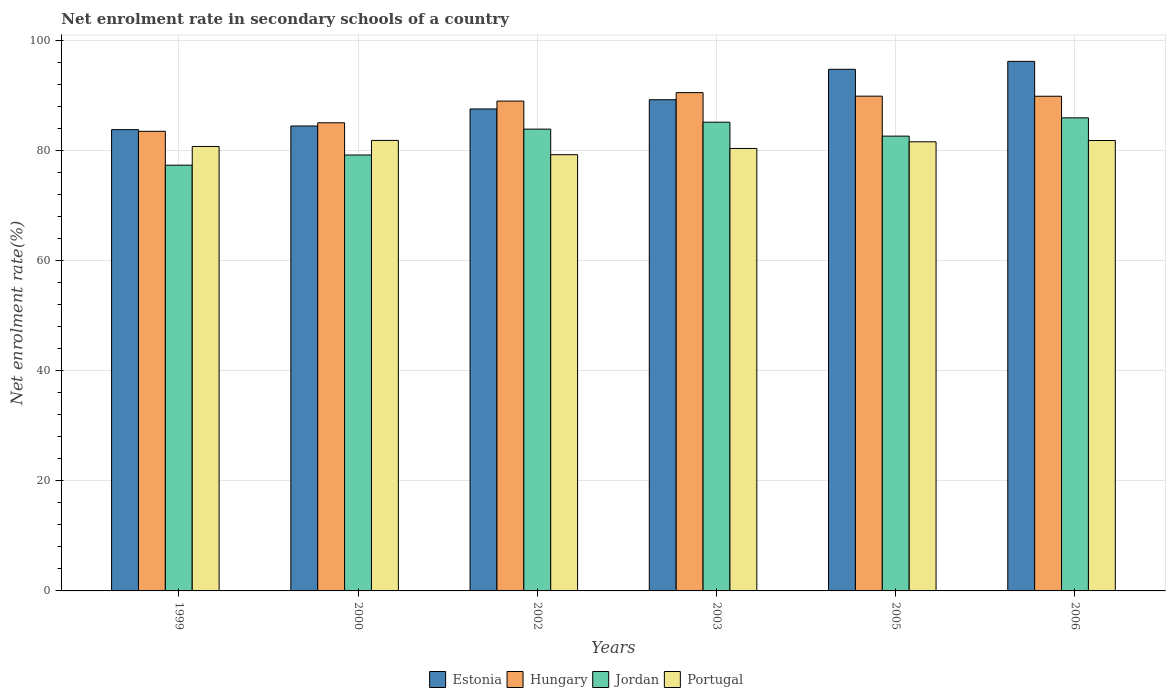How many different coloured bars are there?
Provide a short and direct response. 4. Are the number of bars on each tick of the X-axis equal?
Provide a succinct answer. Yes. How many bars are there on the 3rd tick from the right?
Offer a terse response. 4. What is the net enrolment rate in secondary schools in Hungary in 2005?
Your answer should be compact. 89.93. Across all years, what is the maximum net enrolment rate in secondary schools in Jordan?
Ensure brevity in your answer.  85.99. Across all years, what is the minimum net enrolment rate in secondary schools in Jordan?
Offer a very short reply. 77.39. In which year was the net enrolment rate in secondary schools in Jordan maximum?
Provide a succinct answer. 2006. In which year was the net enrolment rate in secondary schools in Hungary minimum?
Offer a very short reply. 1999. What is the total net enrolment rate in secondary schools in Estonia in the graph?
Offer a very short reply. 536.3. What is the difference between the net enrolment rate in secondary schools in Jordan in 2005 and that in 2006?
Ensure brevity in your answer.  -3.32. What is the difference between the net enrolment rate in secondary schools in Hungary in 2005 and the net enrolment rate in secondary schools in Portugal in 2002?
Provide a short and direct response. 10.64. What is the average net enrolment rate in secondary schools in Jordan per year?
Your response must be concise. 82.4. In the year 2002, what is the difference between the net enrolment rate in secondary schools in Portugal and net enrolment rate in secondary schools in Jordan?
Your response must be concise. -4.65. What is the ratio of the net enrolment rate in secondary schools in Portugal in 2003 to that in 2005?
Offer a terse response. 0.99. Is the difference between the net enrolment rate in secondary schools in Portugal in 2003 and 2006 greater than the difference between the net enrolment rate in secondary schools in Jordan in 2003 and 2006?
Offer a very short reply. No. What is the difference between the highest and the second highest net enrolment rate in secondary schools in Portugal?
Your answer should be compact. 0.02. What is the difference between the highest and the lowest net enrolment rate in secondary schools in Estonia?
Give a very brief answer. 12.41. Is the sum of the net enrolment rate in secondary schools in Portugal in 1999 and 2000 greater than the maximum net enrolment rate in secondary schools in Estonia across all years?
Provide a succinct answer. Yes. What does the 3rd bar from the left in 2003 represents?
Offer a very short reply. Jordan. Is it the case that in every year, the sum of the net enrolment rate in secondary schools in Jordan and net enrolment rate in secondary schools in Hungary is greater than the net enrolment rate in secondary schools in Estonia?
Your response must be concise. Yes. How many bars are there?
Provide a short and direct response. 24. Are the values on the major ticks of Y-axis written in scientific E-notation?
Your answer should be compact. No. How many legend labels are there?
Make the answer very short. 4. How are the legend labels stacked?
Make the answer very short. Horizontal. What is the title of the graph?
Your answer should be very brief. Net enrolment rate in secondary schools of a country. Does "Sweden" appear as one of the legend labels in the graph?
Make the answer very short. No. What is the label or title of the Y-axis?
Offer a very short reply. Net enrolment rate(%). What is the Net enrolment rate(%) in Estonia in 1999?
Your answer should be compact. 83.84. What is the Net enrolment rate(%) of Hungary in 1999?
Offer a terse response. 83.54. What is the Net enrolment rate(%) of Jordan in 1999?
Your response must be concise. 77.39. What is the Net enrolment rate(%) of Portugal in 1999?
Your answer should be very brief. 80.78. What is the Net enrolment rate(%) in Estonia in 2000?
Your answer should be compact. 84.51. What is the Net enrolment rate(%) of Hungary in 2000?
Ensure brevity in your answer.  85.09. What is the Net enrolment rate(%) of Jordan in 2000?
Offer a terse response. 79.23. What is the Net enrolment rate(%) in Portugal in 2000?
Your answer should be compact. 81.89. What is the Net enrolment rate(%) of Estonia in 2002?
Give a very brief answer. 87.6. What is the Net enrolment rate(%) in Hungary in 2002?
Offer a terse response. 89.03. What is the Net enrolment rate(%) in Jordan in 2002?
Provide a short and direct response. 83.94. What is the Net enrolment rate(%) in Portugal in 2002?
Offer a terse response. 79.29. What is the Net enrolment rate(%) of Estonia in 2003?
Give a very brief answer. 89.28. What is the Net enrolment rate(%) in Hungary in 2003?
Give a very brief answer. 90.57. What is the Net enrolment rate(%) in Jordan in 2003?
Offer a very short reply. 85.2. What is the Net enrolment rate(%) of Portugal in 2003?
Your answer should be very brief. 80.42. What is the Net enrolment rate(%) in Estonia in 2005?
Provide a short and direct response. 94.81. What is the Net enrolment rate(%) of Hungary in 2005?
Give a very brief answer. 89.93. What is the Net enrolment rate(%) in Jordan in 2005?
Offer a terse response. 82.66. What is the Net enrolment rate(%) of Portugal in 2005?
Your answer should be very brief. 81.64. What is the Net enrolment rate(%) of Estonia in 2006?
Your response must be concise. 96.26. What is the Net enrolment rate(%) in Hungary in 2006?
Provide a short and direct response. 89.91. What is the Net enrolment rate(%) in Jordan in 2006?
Your answer should be compact. 85.99. What is the Net enrolment rate(%) of Portugal in 2006?
Your answer should be very brief. 81.87. Across all years, what is the maximum Net enrolment rate(%) in Estonia?
Provide a succinct answer. 96.26. Across all years, what is the maximum Net enrolment rate(%) of Hungary?
Your response must be concise. 90.57. Across all years, what is the maximum Net enrolment rate(%) in Jordan?
Offer a terse response. 85.99. Across all years, what is the maximum Net enrolment rate(%) of Portugal?
Your answer should be very brief. 81.89. Across all years, what is the minimum Net enrolment rate(%) in Estonia?
Offer a very short reply. 83.84. Across all years, what is the minimum Net enrolment rate(%) in Hungary?
Your response must be concise. 83.54. Across all years, what is the minimum Net enrolment rate(%) of Jordan?
Your answer should be very brief. 77.39. Across all years, what is the minimum Net enrolment rate(%) of Portugal?
Offer a very short reply. 79.29. What is the total Net enrolment rate(%) in Estonia in the graph?
Your response must be concise. 536.3. What is the total Net enrolment rate(%) of Hungary in the graph?
Ensure brevity in your answer.  528.08. What is the total Net enrolment rate(%) in Jordan in the graph?
Give a very brief answer. 494.41. What is the total Net enrolment rate(%) in Portugal in the graph?
Ensure brevity in your answer.  485.89. What is the difference between the Net enrolment rate(%) in Estonia in 1999 and that in 2000?
Your answer should be compact. -0.66. What is the difference between the Net enrolment rate(%) of Hungary in 1999 and that in 2000?
Your answer should be compact. -1.55. What is the difference between the Net enrolment rate(%) of Jordan in 1999 and that in 2000?
Your response must be concise. -1.85. What is the difference between the Net enrolment rate(%) of Portugal in 1999 and that in 2000?
Your response must be concise. -1.1. What is the difference between the Net enrolment rate(%) in Estonia in 1999 and that in 2002?
Offer a terse response. -3.76. What is the difference between the Net enrolment rate(%) in Hungary in 1999 and that in 2002?
Your answer should be very brief. -5.49. What is the difference between the Net enrolment rate(%) in Jordan in 1999 and that in 2002?
Ensure brevity in your answer.  -6.55. What is the difference between the Net enrolment rate(%) in Portugal in 1999 and that in 2002?
Your response must be concise. 1.49. What is the difference between the Net enrolment rate(%) in Estonia in 1999 and that in 2003?
Make the answer very short. -5.44. What is the difference between the Net enrolment rate(%) of Hungary in 1999 and that in 2003?
Offer a terse response. -7.03. What is the difference between the Net enrolment rate(%) in Jordan in 1999 and that in 2003?
Keep it short and to the point. -7.81. What is the difference between the Net enrolment rate(%) in Portugal in 1999 and that in 2003?
Ensure brevity in your answer.  0.36. What is the difference between the Net enrolment rate(%) in Estonia in 1999 and that in 2005?
Your answer should be compact. -10.97. What is the difference between the Net enrolment rate(%) in Hungary in 1999 and that in 2005?
Ensure brevity in your answer.  -6.39. What is the difference between the Net enrolment rate(%) of Jordan in 1999 and that in 2005?
Offer a terse response. -5.28. What is the difference between the Net enrolment rate(%) in Portugal in 1999 and that in 2005?
Your answer should be compact. -0.85. What is the difference between the Net enrolment rate(%) of Estonia in 1999 and that in 2006?
Your response must be concise. -12.41. What is the difference between the Net enrolment rate(%) in Hungary in 1999 and that in 2006?
Your answer should be compact. -6.37. What is the difference between the Net enrolment rate(%) in Jordan in 1999 and that in 2006?
Your response must be concise. -8.6. What is the difference between the Net enrolment rate(%) of Portugal in 1999 and that in 2006?
Give a very brief answer. -1.09. What is the difference between the Net enrolment rate(%) in Estonia in 2000 and that in 2002?
Offer a very short reply. -3.1. What is the difference between the Net enrolment rate(%) in Hungary in 2000 and that in 2002?
Ensure brevity in your answer.  -3.95. What is the difference between the Net enrolment rate(%) of Jordan in 2000 and that in 2002?
Give a very brief answer. -4.7. What is the difference between the Net enrolment rate(%) of Portugal in 2000 and that in 2002?
Your answer should be very brief. 2.6. What is the difference between the Net enrolment rate(%) in Estonia in 2000 and that in 2003?
Offer a very short reply. -4.78. What is the difference between the Net enrolment rate(%) of Hungary in 2000 and that in 2003?
Your answer should be very brief. -5.48. What is the difference between the Net enrolment rate(%) of Jordan in 2000 and that in 2003?
Your answer should be very brief. -5.97. What is the difference between the Net enrolment rate(%) in Portugal in 2000 and that in 2003?
Ensure brevity in your answer.  1.46. What is the difference between the Net enrolment rate(%) of Estonia in 2000 and that in 2005?
Offer a terse response. -10.31. What is the difference between the Net enrolment rate(%) of Hungary in 2000 and that in 2005?
Keep it short and to the point. -4.84. What is the difference between the Net enrolment rate(%) in Jordan in 2000 and that in 2005?
Your response must be concise. -3.43. What is the difference between the Net enrolment rate(%) in Estonia in 2000 and that in 2006?
Your answer should be compact. -11.75. What is the difference between the Net enrolment rate(%) in Hungary in 2000 and that in 2006?
Make the answer very short. -4.83. What is the difference between the Net enrolment rate(%) of Jordan in 2000 and that in 2006?
Your answer should be compact. -6.76. What is the difference between the Net enrolment rate(%) in Portugal in 2000 and that in 2006?
Offer a terse response. 0.02. What is the difference between the Net enrolment rate(%) in Estonia in 2002 and that in 2003?
Your response must be concise. -1.68. What is the difference between the Net enrolment rate(%) in Hungary in 2002 and that in 2003?
Keep it short and to the point. -1.54. What is the difference between the Net enrolment rate(%) in Jordan in 2002 and that in 2003?
Provide a succinct answer. -1.26. What is the difference between the Net enrolment rate(%) of Portugal in 2002 and that in 2003?
Make the answer very short. -1.13. What is the difference between the Net enrolment rate(%) in Estonia in 2002 and that in 2005?
Make the answer very short. -7.21. What is the difference between the Net enrolment rate(%) of Hungary in 2002 and that in 2005?
Provide a short and direct response. -0.89. What is the difference between the Net enrolment rate(%) in Jordan in 2002 and that in 2005?
Provide a short and direct response. 1.27. What is the difference between the Net enrolment rate(%) of Portugal in 2002 and that in 2005?
Make the answer very short. -2.35. What is the difference between the Net enrolment rate(%) of Estonia in 2002 and that in 2006?
Provide a short and direct response. -8.65. What is the difference between the Net enrolment rate(%) of Hungary in 2002 and that in 2006?
Make the answer very short. -0.88. What is the difference between the Net enrolment rate(%) of Jordan in 2002 and that in 2006?
Offer a very short reply. -2.05. What is the difference between the Net enrolment rate(%) in Portugal in 2002 and that in 2006?
Offer a very short reply. -2.58. What is the difference between the Net enrolment rate(%) of Estonia in 2003 and that in 2005?
Offer a terse response. -5.53. What is the difference between the Net enrolment rate(%) in Hungary in 2003 and that in 2005?
Your answer should be very brief. 0.64. What is the difference between the Net enrolment rate(%) in Jordan in 2003 and that in 2005?
Offer a terse response. 2.53. What is the difference between the Net enrolment rate(%) of Portugal in 2003 and that in 2005?
Offer a very short reply. -1.21. What is the difference between the Net enrolment rate(%) in Estonia in 2003 and that in 2006?
Provide a succinct answer. -6.97. What is the difference between the Net enrolment rate(%) of Hungary in 2003 and that in 2006?
Provide a short and direct response. 0.66. What is the difference between the Net enrolment rate(%) of Jordan in 2003 and that in 2006?
Your answer should be very brief. -0.79. What is the difference between the Net enrolment rate(%) of Portugal in 2003 and that in 2006?
Offer a terse response. -1.45. What is the difference between the Net enrolment rate(%) of Estonia in 2005 and that in 2006?
Make the answer very short. -1.44. What is the difference between the Net enrolment rate(%) in Hungary in 2005 and that in 2006?
Give a very brief answer. 0.01. What is the difference between the Net enrolment rate(%) in Jordan in 2005 and that in 2006?
Offer a terse response. -3.32. What is the difference between the Net enrolment rate(%) of Portugal in 2005 and that in 2006?
Provide a short and direct response. -0.23. What is the difference between the Net enrolment rate(%) of Estonia in 1999 and the Net enrolment rate(%) of Hungary in 2000?
Offer a very short reply. -1.25. What is the difference between the Net enrolment rate(%) of Estonia in 1999 and the Net enrolment rate(%) of Jordan in 2000?
Make the answer very short. 4.61. What is the difference between the Net enrolment rate(%) in Estonia in 1999 and the Net enrolment rate(%) in Portugal in 2000?
Your answer should be very brief. 1.96. What is the difference between the Net enrolment rate(%) of Hungary in 1999 and the Net enrolment rate(%) of Jordan in 2000?
Offer a terse response. 4.31. What is the difference between the Net enrolment rate(%) in Hungary in 1999 and the Net enrolment rate(%) in Portugal in 2000?
Give a very brief answer. 1.66. What is the difference between the Net enrolment rate(%) in Jordan in 1999 and the Net enrolment rate(%) in Portugal in 2000?
Offer a very short reply. -4.5. What is the difference between the Net enrolment rate(%) in Estonia in 1999 and the Net enrolment rate(%) in Hungary in 2002?
Your response must be concise. -5.19. What is the difference between the Net enrolment rate(%) of Estonia in 1999 and the Net enrolment rate(%) of Jordan in 2002?
Provide a short and direct response. -0.1. What is the difference between the Net enrolment rate(%) in Estonia in 1999 and the Net enrolment rate(%) in Portugal in 2002?
Make the answer very short. 4.55. What is the difference between the Net enrolment rate(%) in Hungary in 1999 and the Net enrolment rate(%) in Jordan in 2002?
Provide a succinct answer. -0.39. What is the difference between the Net enrolment rate(%) of Hungary in 1999 and the Net enrolment rate(%) of Portugal in 2002?
Offer a terse response. 4.25. What is the difference between the Net enrolment rate(%) of Jordan in 1999 and the Net enrolment rate(%) of Portugal in 2002?
Offer a very short reply. -1.91. What is the difference between the Net enrolment rate(%) of Estonia in 1999 and the Net enrolment rate(%) of Hungary in 2003?
Offer a terse response. -6.73. What is the difference between the Net enrolment rate(%) of Estonia in 1999 and the Net enrolment rate(%) of Jordan in 2003?
Keep it short and to the point. -1.36. What is the difference between the Net enrolment rate(%) of Estonia in 1999 and the Net enrolment rate(%) of Portugal in 2003?
Keep it short and to the point. 3.42. What is the difference between the Net enrolment rate(%) of Hungary in 1999 and the Net enrolment rate(%) of Jordan in 2003?
Offer a very short reply. -1.66. What is the difference between the Net enrolment rate(%) in Hungary in 1999 and the Net enrolment rate(%) in Portugal in 2003?
Provide a succinct answer. 3.12. What is the difference between the Net enrolment rate(%) in Jordan in 1999 and the Net enrolment rate(%) in Portugal in 2003?
Offer a terse response. -3.04. What is the difference between the Net enrolment rate(%) in Estonia in 1999 and the Net enrolment rate(%) in Hungary in 2005?
Your answer should be very brief. -6.09. What is the difference between the Net enrolment rate(%) of Estonia in 1999 and the Net enrolment rate(%) of Jordan in 2005?
Your response must be concise. 1.18. What is the difference between the Net enrolment rate(%) of Estonia in 1999 and the Net enrolment rate(%) of Portugal in 2005?
Provide a succinct answer. 2.21. What is the difference between the Net enrolment rate(%) of Hungary in 1999 and the Net enrolment rate(%) of Jordan in 2005?
Your answer should be very brief. 0.88. What is the difference between the Net enrolment rate(%) of Hungary in 1999 and the Net enrolment rate(%) of Portugal in 2005?
Your answer should be very brief. 1.91. What is the difference between the Net enrolment rate(%) in Jordan in 1999 and the Net enrolment rate(%) in Portugal in 2005?
Provide a short and direct response. -4.25. What is the difference between the Net enrolment rate(%) of Estonia in 1999 and the Net enrolment rate(%) of Hungary in 2006?
Provide a succinct answer. -6.07. What is the difference between the Net enrolment rate(%) in Estonia in 1999 and the Net enrolment rate(%) in Jordan in 2006?
Keep it short and to the point. -2.15. What is the difference between the Net enrolment rate(%) in Estonia in 1999 and the Net enrolment rate(%) in Portugal in 2006?
Provide a short and direct response. 1.97. What is the difference between the Net enrolment rate(%) in Hungary in 1999 and the Net enrolment rate(%) in Jordan in 2006?
Your answer should be compact. -2.44. What is the difference between the Net enrolment rate(%) in Hungary in 1999 and the Net enrolment rate(%) in Portugal in 2006?
Provide a succinct answer. 1.67. What is the difference between the Net enrolment rate(%) of Jordan in 1999 and the Net enrolment rate(%) of Portugal in 2006?
Make the answer very short. -4.48. What is the difference between the Net enrolment rate(%) of Estonia in 2000 and the Net enrolment rate(%) of Hungary in 2002?
Keep it short and to the point. -4.53. What is the difference between the Net enrolment rate(%) in Estonia in 2000 and the Net enrolment rate(%) in Jordan in 2002?
Provide a succinct answer. 0.57. What is the difference between the Net enrolment rate(%) in Estonia in 2000 and the Net enrolment rate(%) in Portugal in 2002?
Your answer should be very brief. 5.22. What is the difference between the Net enrolment rate(%) of Hungary in 2000 and the Net enrolment rate(%) of Jordan in 2002?
Keep it short and to the point. 1.15. What is the difference between the Net enrolment rate(%) in Hungary in 2000 and the Net enrolment rate(%) in Portugal in 2002?
Your response must be concise. 5.8. What is the difference between the Net enrolment rate(%) of Jordan in 2000 and the Net enrolment rate(%) of Portugal in 2002?
Your response must be concise. -0.06. What is the difference between the Net enrolment rate(%) of Estonia in 2000 and the Net enrolment rate(%) of Hungary in 2003?
Provide a short and direct response. -6.07. What is the difference between the Net enrolment rate(%) in Estonia in 2000 and the Net enrolment rate(%) in Jordan in 2003?
Give a very brief answer. -0.69. What is the difference between the Net enrolment rate(%) in Estonia in 2000 and the Net enrolment rate(%) in Portugal in 2003?
Offer a terse response. 4.08. What is the difference between the Net enrolment rate(%) in Hungary in 2000 and the Net enrolment rate(%) in Jordan in 2003?
Offer a very short reply. -0.11. What is the difference between the Net enrolment rate(%) of Hungary in 2000 and the Net enrolment rate(%) of Portugal in 2003?
Your answer should be compact. 4.66. What is the difference between the Net enrolment rate(%) of Jordan in 2000 and the Net enrolment rate(%) of Portugal in 2003?
Ensure brevity in your answer.  -1.19. What is the difference between the Net enrolment rate(%) of Estonia in 2000 and the Net enrolment rate(%) of Hungary in 2005?
Provide a short and direct response. -5.42. What is the difference between the Net enrolment rate(%) in Estonia in 2000 and the Net enrolment rate(%) in Jordan in 2005?
Your answer should be compact. 1.84. What is the difference between the Net enrolment rate(%) of Estonia in 2000 and the Net enrolment rate(%) of Portugal in 2005?
Offer a very short reply. 2.87. What is the difference between the Net enrolment rate(%) in Hungary in 2000 and the Net enrolment rate(%) in Jordan in 2005?
Provide a succinct answer. 2.42. What is the difference between the Net enrolment rate(%) of Hungary in 2000 and the Net enrolment rate(%) of Portugal in 2005?
Your answer should be very brief. 3.45. What is the difference between the Net enrolment rate(%) in Jordan in 2000 and the Net enrolment rate(%) in Portugal in 2005?
Keep it short and to the point. -2.4. What is the difference between the Net enrolment rate(%) in Estonia in 2000 and the Net enrolment rate(%) in Hungary in 2006?
Offer a very short reply. -5.41. What is the difference between the Net enrolment rate(%) of Estonia in 2000 and the Net enrolment rate(%) of Jordan in 2006?
Ensure brevity in your answer.  -1.48. What is the difference between the Net enrolment rate(%) in Estonia in 2000 and the Net enrolment rate(%) in Portugal in 2006?
Provide a short and direct response. 2.64. What is the difference between the Net enrolment rate(%) in Hungary in 2000 and the Net enrolment rate(%) in Jordan in 2006?
Offer a terse response. -0.9. What is the difference between the Net enrolment rate(%) in Hungary in 2000 and the Net enrolment rate(%) in Portugal in 2006?
Ensure brevity in your answer.  3.22. What is the difference between the Net enrolment rate(%) of Jordan in 2000 and the Net enrolment rate(%) of Portugal in 2006?
Offer a terse response. -2.64. What is the difference between the Net enrolment rate(%) of Estonia in 2002 and the Net enrolment rate(%) of Hungary in 2003?
Your response must be concise. -2.97. What is the difference between the Net enrolment rate(%) in Estonia in 2002 and the Net enrolment rate(%) in Jordan in 2003?
Make the answer very short. 2.4. What is the difference between the Net enrolment rate(%) in Estonia in 2002 and the Net enrolment rate(%) in Portugal in 2003?
Keep it short and to the point. 7.18. What is the difference between the Net enrolment rate(%) in Hungary in 2002 and the Net enrolment rate(%) in Jordan in 2003?
Make the answer very short. 3.84. What is the difference between the Net enrolment rate(%) of Hungary in 2002 and the Net enrolment rate(%) of Portugal in 2003?
Offer a very short reply. 8.61. What is the difference between the Net enrolment rate(%) of Jordan in 2002 and the Net enrolment rate(%) of Portugal in 2003?
Provide a short and direct response. 3.51. What is the difference between the Net enrolment rate(%) in Estonia in 2002 and the Net enrolment rate(%) in Hungary in 2005?
Make the answer very short. -2.33. What is the difference between the Net enrolment rate(%) in Estonia in 2002 and the Net enrolment rate(%) in Jordan in 2005?
Your answer should be compact. 4.94. What is the difference between the Net enrolment rate(%) in Estonia in 2002 and the Net enrolment rate(%) in Portugal in 2005?
Your answer should be very brief. 5.97. What is the difference between the Net enrolment rate(%) in Hungary in 2002 and the Net enrolment rate(%) in Jordan in 2005?
Make the answer very short. 6.37. What is the difference between the Net enrolment rate(%) in Hungary in 2002 and the Net enrolment rate(%) in Portugal in 2005?
Provide a short and direct response. 7.4. What is the difference between the Net enrolment rate(%) in Jordan in 2002 and the Net enrolment rate(%) in Portugal in 2005?
Ensure brevity in your answer.  2.3. What is the difference between the Net enrolment rate(%) of Estonia in 2002 and the Net enrolment rate(%) of Hungary in 2006?
Keep it short and to the point. -2.31. What is the difference between the Net enrolment rate(%) of Estonia in 2002 and the Net enrolment rate(%) of Jordan in 2006?
Provide a short and direct response. 1.62. What is the difference between the Net enrolment rate(%) in Estonia in 2002 and the Net enrolment rate(%) in Portugal in 2006?
Make the answer very short. 5.73. What is the difference between the Net enrolment rate(%) in Hungary in 2002 and the Net enrolment rate(%) in Jordan in 2006?
Make the answer very short. 3.05. What is the difference between the Net enrolment rate(%) in Hungary in 2002 and the Net enrolment rate(%) in Portugal in 2006?
Make the answer very short. 7.17. What is the difference between the Net enrolment rate(%) of Jordan in 2002 and the Net enrolment rate(%) of Portugal in 2006?
Your response must be concise. 2.07. What is the difference between the Net enrolment rate(%) of Estonia in 2003 and the Net enrolment rate(%) of Hungary in 2005?
Your answer should be very brief. -0.65. What is the difference between the Net enrolment rate(%) in Estonia in 2003 and the Net enrolment rate(%) in Jordan in 2005?
Make the answer very short. 6.62. What is the difference between the Net enrolment rate(%) in Estonia in 2003 and the Net enrolment rate(%) in Portugal in 2005?
Offer a terse response. 7.65. What is the difference between the Net enrolment rate(%) of Hungary in 2003 and the Net enrolment rate(%) of Jordan in 2005?
Provide a short and direct response. 7.91. What is the difference between the Net enrolment rate(%) in Hungary in 2003 and the Net enrolment rate(%) in Portugal in 2005?
Keep it short and to the point. 8.94. What is the difference between the Net enrolment rate(%) of Jordan in 2003 and the Net enrolment rate(%) of Portugal in 2005?
Provide a succinct answer. 3.56. What is the difference between the Net enrolment rate(%) of Estonia in 2003 and the Net enrolment rate(%) of Hungary in 2006?
Ensure brevity in your answer.  -0.63. What is the difference between the Net enrolment rate(%) of Estonia in 2003 and the Net enrolment rate(%) of Jordan in 2006?
Provide a short and direct response. 3.29. What is the difference between the Net enrolment rate(%) in Estonia in 2003 and the Net enrolment rate(%) in Portugal in 2006?
Offer a terse response. 7.41. What is the difference between the Net enrolment rate(%) in Hungary in 2003 and the Net enrolment rate(%) in Jordan in 2006?
Provide a succinct answer. 4.58. What is the difference between the Net enrolment rate(%) of Hungary in 2003 and the Net enrolment rate(%) of Portugal in 2006?
Ensure brevity in your answer.  8.7. What is the difference between the Net enrolment rate(%) in Jordan in 2003 and the Net enrolment rate(%) in Portugal in 2006?
Offer a terse response. 3.33. What is the difference between the Net enrolment rate(%) in Estonia in 2005 and the Net enrolment rate(%) in Hungary in 2006?
Ensure brevity in your answer.  4.9. What is the difference between the Net enrolment rate(%) of Estonia in 2005 and the Net enrolment rate(%) of Jordan in 2006?
Your response must be concise. 8.83. What is the difference between the Net enrolment rate(%) in Estonia in 2005 and the Net enrolment rate(%) in Portugal in 2006?
Provide a succinct answer. 12.94. What is the difference between the Net enrolment rate(%) in Hungary in 2005 and the Net enrolment rate(%) in Jordan in 2006?
Keep it short and to the point. 3.94. What is the difference between the Net enrolment rate(%) in Hungary in 2005 and the Net enrolment rate(%) in Portugal in 2006?
Ensure brevity in your answer.  8.06. What is the difference between the Net enrolment rate(%) of Jordan in 2005 and the Net enrolment rate(%) of Portugal in 2006?
Offer a terse response. 0.79. What is the average Net enrolment rate(%) in Estonia per year?
Provide a succinct answer. 89.38. What is the average Net enrolment rate(%) in Hungary per year?
Keep it short and to the point. 88.01. What is the average Net enrolment rate(%) of Jordan per year?
Make the answer very short. 82.4. What is the average Net enrolment rate(%) of Portugal per year?
Ensure brevity in your answer.  80.98. In the year 1999, what is the difference between the Net enrolment rate(%) in Estonia and Net enrolment rate(%) in Hungary?
Your answer should be compact. 0.3. In the year 1999, what is the difference between the Net enrolment rate(%) in Estonia and Net enrolment rate(%) in Jordan?
Give a very brief answer. 6.46. In the year 1999, what is the difference between the Net enrolment rate(%) of Estonia and Net enrolment rate(%) of Portugal?
Keep it short and to the point. 3.06. In the year 1999, what is the difference between the Net enrolment rate(%) in Hungary and Net enrolment rate(%) in Jordan?
Offer a terse response. 6.16. In the year 1999, what is the difference between the Net enrolment rate(%) in Hungary and Net enrolment rate(%) in Portugal?
Your answer should be very brief. 2.76. In the year 1999, what is the difference between the Net enrolment rate(%) of Jordan and Net enrolment rate(%) of Portugal?
Ensure brevity in your answer.  -3.4. In the year 2000, what is the difference between the Net enrolment rate(%) of Estonia and Net enrolment rate(%) of Hungary?
Keep it short and to the point. -0.58. In the year 2000, what is the difference between the Net enrolment rate(%) of Estonia and Net enrolment rate(%) of Jordan?
Your answer should be compact. 5.27. In the year 2000, what is the difference between the Net enrolment rate(%) of Estonia and Net enrolment rate(%) of Portugal?
Give a very brief answer. 2.62. In the year 2000, what is the difference between the Net enrolment rate(%) in Hungary and Net enrolment rate(%) in Jordan?
Your response must be concise. 5.86. In the year 2000, what is the difference between the Net enrolment rate(%) of Hungary and Net enrolment rate(%) of Portugal?
Ensure brevity in your answer.  3.2. In the year 2000, what is the difference between the Net enrolment rate(%) in Jordan and Net enrolment rate(%) in Portugal?
Make the answer very short. -2.65. In the year 2002, what is the difference between the Net enrolment rate(%) in Estonia and Net enrolment rate(%) in Hungary?
Give a very brief answer. -1.43. In the year 2002, what is the difference between the Net enrolment rate(%) of Estonia and Net enrolment rate(%) of Jordan?
Provide a succinct answer. 3.67. In the year 2002, what is the difference between the Net enrolment rate(%) in Estonia and Net enrolment rate(%) in Portugal?
Your answer should be very brief. 8.31. In the year 2002, what is the difference between the Net enrolment rate(%) in Hungary and Net enrolment rate(%) in Jordan?
Give a very brief answer. 5.1. In the year 2002, what is the difference between the Net enrolment rate(%) in Hungary and Net enrolment rate(%) in Portugal?
Give a very brief answer. 9.74. In the year 2002, what is the difference between the Net enrolment rate(%) in Jordan and Net enrolment rate(%) in Portugal?
Keep it short and to the point. 4.65. In the year 2003, what is the difference between the Net enrolment rate(%) in Estonia and Net enrolment rate(%) in Hungary?
Offer a terse response. -1.29. In the year 2003, what is the difference between the Net enrolment rate(%) of Estonia and Net enrolment rate(%) of Jordan?
Keep it short and to the point. 4.08. In the year 2003, what is the difference between the Net enrolment rate(%) of Estonia and Net enrolment rate(%) of Portugal?
Your response must be concise. 8.86. In the year 2003, what is the difference between the Net enrolment rate(%) of Hungary and Net enrolment rate(%) of Jordan?
Your response must be concise. 5.37. In the year 2003, what is the difference between the Net enrolment rate(%) of Hungary and Net enrolment rate(%) of Portugal?
Provide a short and direct response. 10.15. In the year 2003, what is the difference between the Net enrolment rate(%) in Jordan and Net enrolment rate(%) in Portugal?
Make the answer very short. 4.77. In the year 2005, what is the difference between the Net enrolment rate(%) in Estonia and Net enrolment rate(%) in Hungary?
Make the answer very short. 4.88. In the year 2005, what is the difference between the Net enrolment rate(%) in Estonia and Net enrolment rate(%) in Jordan?
Ensure brevity in your answer.  12.15. In the year 2005, what is the difference between the Net enrolment rate(%) of Estonia and Net enrolment rate(%) of Portugal?
Make the answer very short. 13.18. In the year 2005, what is the difference between the Net enrolment rate(%) in Hungary and Net enrolment rate(%) in Jordan?
Give a very brief answer. 7.27. In the year 2005, what is the difference between the Net enrolment rate(%) in Hungary and Net enrolment rate(%) in Portugal?
Ensure brevity in your answer.  8.29. In the year 2005, what is the difference between the Net enrolment rate(%) of Jordan and Net enrolment rate(%) of Portugal?
Your response must be concise. 1.03. In the year 2006, what is the difference between the Net enrolment rate(%) in Estonia and Net enrolment rate(%) in Hungary?
Offer a terse response. 6.34. In the year 2006, what is the difference between the Net enrolment rate(%) of Estonia and Net enrolment rate(%) of Jordan?
Keep it short and to the point. 10.27. In the year 2006, what is the difference between the Net enrolment rate(%) in Estonia and Net enrolment rate(%) in Portugal?
Provide a succinct answer. 14.39. In the year 2006, what is the difference between the Net enrolment rate(%) of Hungary and Net enrolment rate(%) of Jordan?
Offer a very short reply. 3.93. In the year 2006, what is the difference between the Net enrolment rate(%) of Hungary and Net enrolment rate(%) of Portugal?
Your answer should be very brief. 8.04. In the year 2006, what is the difference between the Net enrolment rate(%) in Jordan and Net enrolment rate(%) in Portugal?
Keep it short and to the point. 4.12. What is the ratio of the Net enrolment rate(%) of Hungary in 1999 to that in 2000?
Offer a terse response. 0.98. What is the ratio of the Net enrolment rate(%) in Jordan in 1999 to that in 2000?
Your answer should be compact. 0.98. What is the ratio of the Net enrolment rate(%) in Portugal in 1999 to that in 2000?
Provide a short and direct response. 0.99. What is the ratio of the Net enrolment rate(%) of Estonia in 1999 to that in 2002?
Your response must be concise. 0.96. What is the ratio of the Net enrolment rate(%) in Hungary in 1999 to that in 2002?
Your answer should be very brief. 0.94. What is the ratio of the Net enrolment rate(%) of Jordan in 1999 to that in 2002?
Make the answer very short. 0.92. What is the ratio of the Net enrolment rate(%) in Portugal in 1999 to that in 2002?
Your answer should be very brief. 1.02. What is the ratio of the Net enrolment rate(%) in Estonia in 1999 to that in 2003?
Your answer should be very brief. 0.94. What is the ratio of the Net enrolment rate(%) in Hungary in 1999 to that in 2003?
Offer a terse response. 0.92. What is the ratio of the Net enrolment rate(%) of Jordan in 1999 to that in 2003?
Ensure brevity in your answer.  0.91. What is the ratio of the Net enrolment rate(%) of Estonia in 1999 to that in 2005?
Provide a short and direct response. 0.88. What is the ratio of the Net enrolment rate(%) in Hungary in 1999 to that in 2005?
Provide a short and direct response. 0.93. What is the ratio of the Net enrolment rate(%) in Jordan in 1999 to that in 2005?
Your answer should be compact. 0.94. What is the ratio of the Net enrolment rate(%) of Portugal in 1999 to that in 2005?
Your answer should be compact. 0.99. What is the ratio of the Net enrolment rate(%) of Estonia in 1999 to that in 2006?
Keep it short and to the point. 0.87. What is the ratio of the Net enrolment rate(%) in Hungary in 1999 to that in 2006?
Your response must be concise. 0.93. What is the ratio of the Net enrolment rate(%) in Portugal in 1999 to that in 2006?
Your response must be concise. 0.99. What is the ratio of the Net enrolment rate(%) of Estonia in 2000 to that in 2002?
Offer a terse response. 0.96. What is the ratio of the Net enrolment rate(%) of Hungary in 2000 to that in 2002?
Provide a short and direct response. 0.96. What is the ratio of the Net enrolment rate(%) in Jordan in 2000 to that in 2002?
Provide a succinct answer. 0.94. What is the ratio of the Net enrolment rate(%) of Portugal in 2000 to that in 2002?
Make the answer very short. 1.03. What is the ratio of the Net enrolment rate(%) in Estonia in 2000 to that in 2003?
Make the answer very short. 0.95. What is the ratio of the Net enrolment rate(%) of Hungary in 2000 to that in 2003?
Provide a succinct answer. 0.94. What is the ratio of the Net enrolment rate(%) of Portugal in 2000 to that in 2003?
Your response must be concise. 1.02. What is the ratio of the Net enrolment rate(%) of Estonia in 2000 to that in 2005?
Offer a very short reply. 0.89. What is the ratio of the Net enrolment rate(%) in Hungary in 2000 to that in 2005?
Your answer should be very brief. 0.95. What is the ratio of the Net enrolment rate(%) of Jordan in 2000 to that in 2005?
Provide a succinct answer. 0.96. What is the ratio of the Net enrolment rate(%) of Portugal in 2000 to that in 2005?
Offer a very short reply. 1. What is the ratio of the Net enrolment rate(%) of Estonia in 2000 to that in 2006?
Your answer should be compact. 0.88. What is the ratio of the Net enrolment rate(%) in Hungary in 2000 to that in 2006?
Provide a short and direct response. 0.95. What is the ratio of the Net enrolment rate(%) of Jordan in 2000 to that in 2006?
Offer a very short reply. 0.92. What is the ratio of the Net enrolment rate(%) of Portugal in 2000 to that in 2006?
Offer a terse response. 1. What is the ratio of the Net enrolment rate(%) of Estonia in 2002 to that in 2003?
Your answer should be compact. 0.98. What is the ratio of the Net enrolment rate(%) of Hungary in 2002 to that in 2003?
Offer a very short reply. 0.98. What is the ratio of the Net enrolment rate(%) of Jordan in 2002 to that in 2003?
Make the answer very short. 0.99. What is the ratio of the Net enrolment rate(%) of Portugal in 2002 to that in 2003?
Offer a terse response. 0.99. What is the ratio of the Net enrolment rate(%) of Estonia in 2002 to that in 2005?
Give a very brief answer. 0.92. What is the ratio of the Net enrolment rate(%) of Hungary in 2002 to that in 2005?
Provide a short and direct response. 0.99. What is the ratio of the Net enrolment rate(%) of Jordan in 2002 to that in 2005?
Provide a succinct answer. 1.02. What is the ratio of the Net enrolment rate(%) of Portugal in 2002 to that in 2005?
Give a very brief answer. 0.97. What is the ratio of the Net enrolment rate(%) of Estonia in 2002 to that in 2006?
Provide a succinct answer. 0.91. What is the ratio of the Net enrolment rate(%) of Hungary in 2002 to that in 2006?
Your answer should be compact. 0.99. What is the ratio of the Net enrolment rate(%) in Jordan in 2002 to that in 2006?
Your response must be concise. 0.98. What is the ratio of the Net enrolment rate(%) in Portugal in 2002 to that in 2006?
Your answer should be very brief. 0.97. What is the ratio of the Net enrolment rate(%) in Estonia in 2003 to that in 2005?
Offer a terse response. 0.94. What is the ratio of the Net enrolment rate(%) in Hungary in 2003 to that in 2005?
Provide a succinct answer. 1.01. What is the ratio of the Net enrolment rate(%) of Jordan in 2003 to that in 2005?
Your answer should be very brief. 1.03. What is the ratio of the Net enrolment rate(%) of Portugal in 2003 to that in 2005?
Provide a short and direct response. 0.99. What is the ratio of the Net enrolment rate(%) in Estonia in 2003 to that in 2006?
Offer a very short reply. 0.93. What is the ratio of the Net enrolment rate(%) of Hungary in 2003 to that in 2006?
Provide a short and direct response. 1.01. What is the ratio of the Net enrolment rate(%) of Jordan in 2003 to that in 2006?
Your answer should be very brief. 0.99. What is the ratio of the Net enrolment rate(%) of Portugal in 2003 to that in 2006?
Give a very brief answer. 0.98. What is the ratio of the Net enrolment rate(%) in Jordan in 2005 to that in 2006?
Provide a short and direct response. 0.96. What is the ratio of the Net enrolment rate(%) of Portugal in 2005 to that in 2006?
Give a very brief answer. 1. What is the difference between the highest and the second highest Net enrolment rate(%) of Estonia?
Make the answer very short. 1.44. What is the difference between the highest and the second highest Net enrolment rate(%) in Hungary?
Make the answer very short. 0.64. What is the difference between the highest and the second highest Net enrolment rate(%) of Jordan?
Your answer should be compact. 0.79. What is the difference between the highest and the second highest Net enrolment rate(%) of Portugal?
Provide a succinct answer. 0.02. What is the difference between the highest and the lowest Net enrolment rate(%) of Estonia?
Your answer should be very brief. 12.41. What is the difference between the highest and the lowest Net enrolment rate(%) of Hungary?
Provide a short and direct response. 7.03. What is the difference between the highest and the lowest Net enrolment rate(%) in Jordan?
Offer a very short reply. 8.6. What is the difference between the highest and the lowest Net enrolment rate(%) of Portugal?
Your answer should be compact. 2.6. 